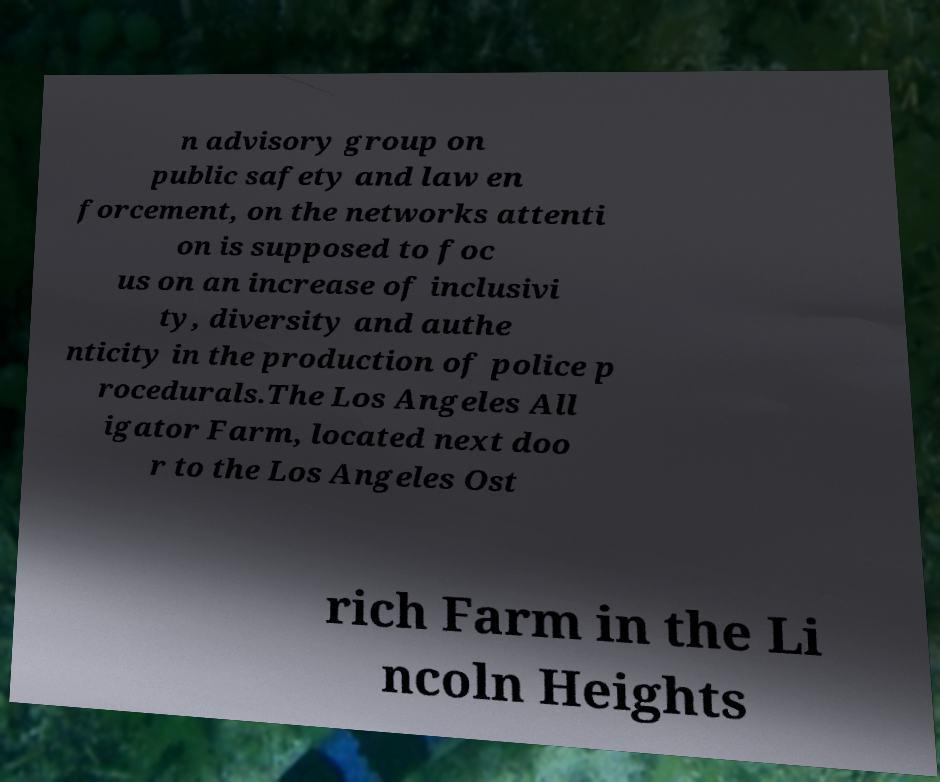For documentation purposes, I need the text within this image transcribed. Could you provide that? n advisory group on public safety and law en forcement, on the networks attenti on is supposed to foc us on an increase of inclusivi ty, diversity and authe nticity in the production of police p rocedurals.The Los Angeles All igator Farm, located next doo r to the Los Angeles Ost rich Farm in the Li ncoln Heights 